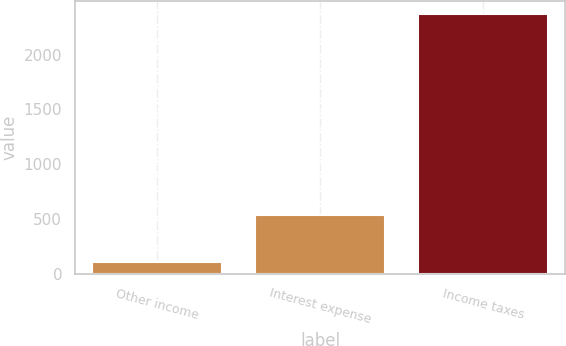<chart> <loc_0><loc_0><loc_500><loc_500><bar_chart><fcel>Other income<fcel>Interest expense<fcel>Income taxes<nl><fcel>108<fcel>535<fcel>2375<nl></chart> 